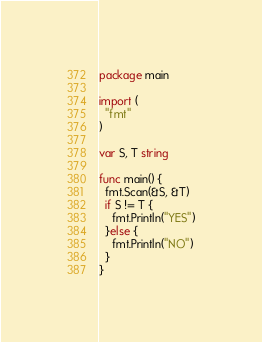<code> <loc_0><loc_0><loc_500><loc_500><_Go_>package main

import (
  "fmt"
)

var S, T string

func main() {
  fmt.Scan(&S, &T)
  if S != T {
    fmt.Println("YES")
  }else {
    fmt.Println("NO")
  }
}</code> 